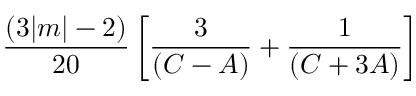<formula> <loc_0><loc_0><loc_500><loc_500>\frac { ( 3 | m | - 2 ) } { 2 0 } \left [ \frac { 3 } { ( C - A ) } + \frac { 1 } { ( C + 3 A ) } \right ]</formula> 